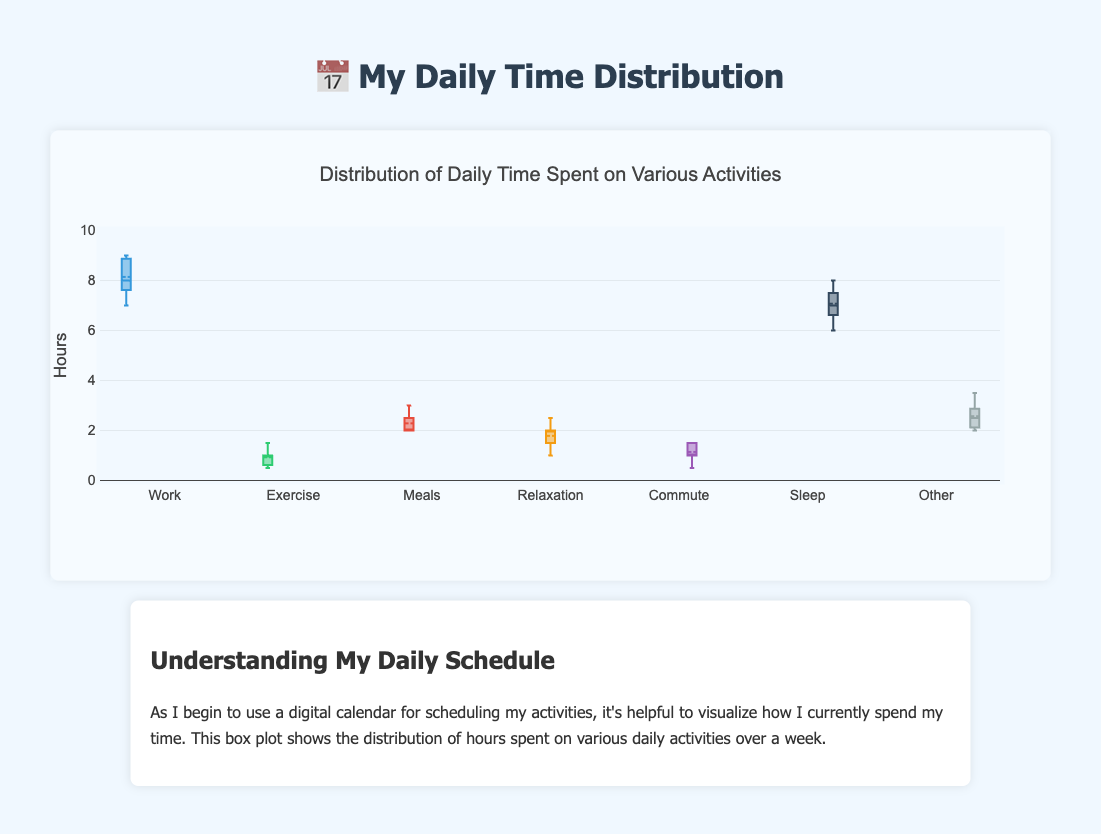What's the title of the figure? The title of the figure is located at the top and states the main subject of the data being represented.
Answer: Distribution of Daily Time Spent on Various Activities How many hours per day is typically spent on work? Observe the box plot for 'Work'. The median line represents the typical value, which is around 8 hours.
Answer: 8 hours Which activity has the highest median time spent per day? Compare the median lines of all box plots. The median for 'Work' is the highest.
Answer: Work What's the range of hours spent on exercise? Observe the minimum and maximum points (whiskers) of the 'Exercise' box plot. The range is from 0.5 to 1.5 hours.
Answer: 0.5 to 1.5 hours What is the average time spent on meals? The box plot shows the mean with a small symbol (typically a dot or a cross). For 'Meals', this is at around 2.3 hours.
Answer: 2.3 hours Which activity shows the most variability in time spent? Look at the interquartile ranges (the lengths of the boxes). 'Other' has a wide box indicating high variability.
Answer: Other How does the median time spent on sleep compare to relaxation? Compare the median lines of 'Sleep' and 'Relaxation'. Sleep's median is higher than Relaxation's median.
Answer: Higher How many activities have a time allocation within the range of 2 to 3 hours? Observe which box plots have their interquartile ranges within or overlapping the 2 to 3-hour range. 'Meals' and 'Other' fit this criterion.
Answer: 2 activities Which activities have any outliers? Look for individual points outside the whiskers of box plots to identify outliers. 'Commute' has outliers.
Answer: Commute What is the interquartile range (IQR) for sleep? IQR is the difference between the third quartile (Q3) and the first quartile (Q1). For 'Sleep', Q1 is around 6.5 and Q3 is around 7.5, so IQR is 7.5 - 6.5.
Answer: 1 hour 